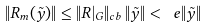Convert formula to latex. <formula><loc_0><loc_0><loc_500><loc_500>\| R _ { m } ( \tilde { y } ) \| \leq \| R | _ { G } \| _ { c b } \, \| \tilde { y } \| < \ e \| \tilde { y } \|</formula> 